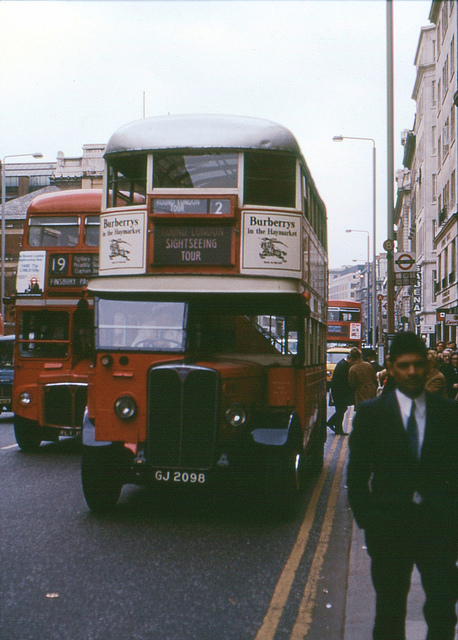Extract all visible text content from this image. SIGHTSEEING TOUR Burberrys 8 GJ 2098 19 2 Barberrys 